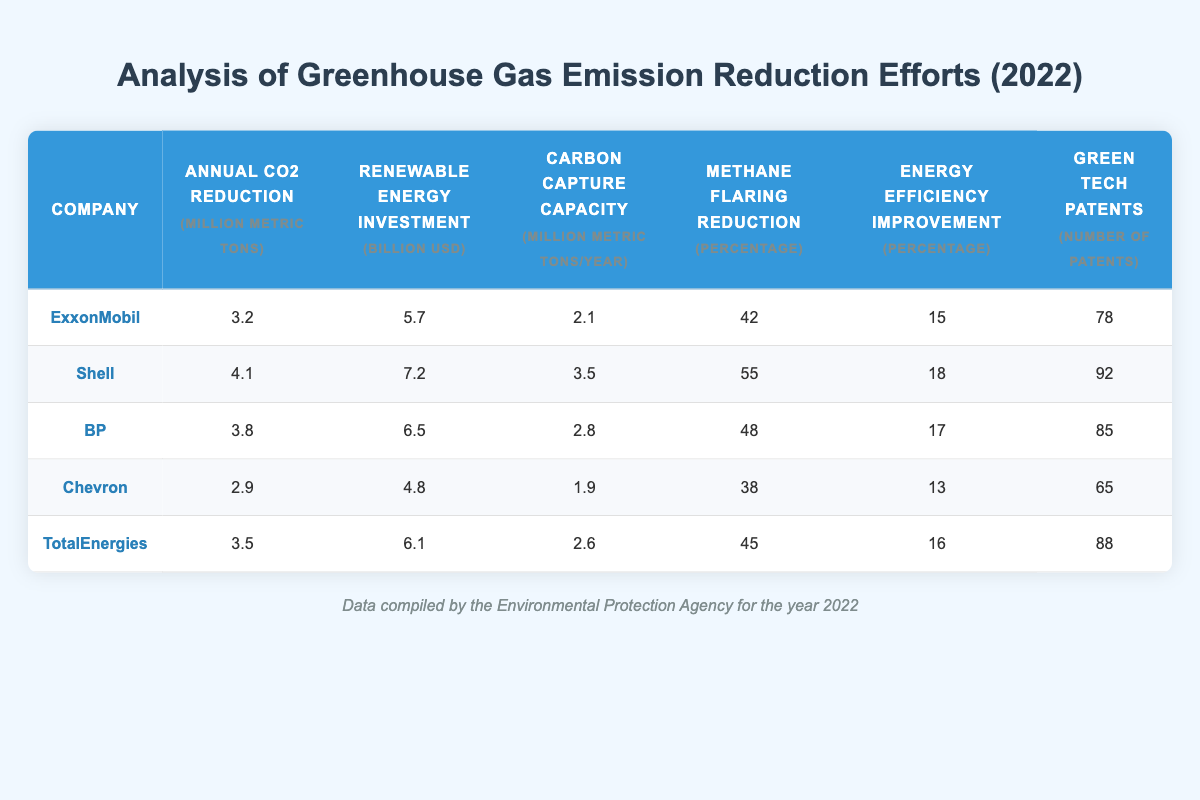What company has the highest annual CO2 reduction? Looking at the "Annual CO2 Reduction" column, Shell has the highest value with 4.1 million metric tons.
Answer: Shell What is the average renewable energy investment among these companies? The renewable energy investments are 5.7, 7.2, 6.5, 4.8, and 6.1 billion USD. The sum is 30.3 billion USD and average is 30.3/5 = 6.06 billion USD.
Answer: 6.06 billion USD Is Chevron's carbon capture capacity greater than ExxonMobil's? Chevron's carbon capture capacity is 1.9 million metric tons per year, while ExxonMobil's is 2.1 million metric tons per year. Since 1.9 is not greater than 2.1, the statement is false.
Answer: No Which company has the highest percentage for energy efficiency improvement? Referring to the "Energy Efficiency Improvement" column, Shell has the highest percentage at 18%.
Answer: Shell What is the total number of green tech patents held by these five companies? The total number of green tech patents is 78 (ExxonMobil) + 92 (Shell) + 85 (BP) + 65 (Chevron) + 88 (TotalEnergies) = 408 patents.
Answer: 408 patents Is the percentage of methane flaring reduction for BP lower than that of TotalEnergies? BP's methane flaring reduction is 48%, whereas TotalEnergies has 45%. Since 48 is greater than 45, the statement is false.
Answer: No How many more million metric tons of CO2 reduction does Shell achieve compared to Chevron? Shell reduces 4.1 million metric tons and Chevron reduces 2.9 million metric tons. The difference is 4.1 - 2.9 = 1.2 million metric tons more.
Answer: 1.2 million metric tons What company has a renewable energy investment of less than 6 billion USD? Reviewing the "Renewable Energy Investment" column, Chevron with 4.8 billion USD is the only company with an investment under 6 billion USD.
Answer: Chevron Which company has the second highest number of green tech patents? Looking at the "Green Tech Patents" column, BP has 85 patents, which is the second highest after Shell (92 patents).
Answer: BP 